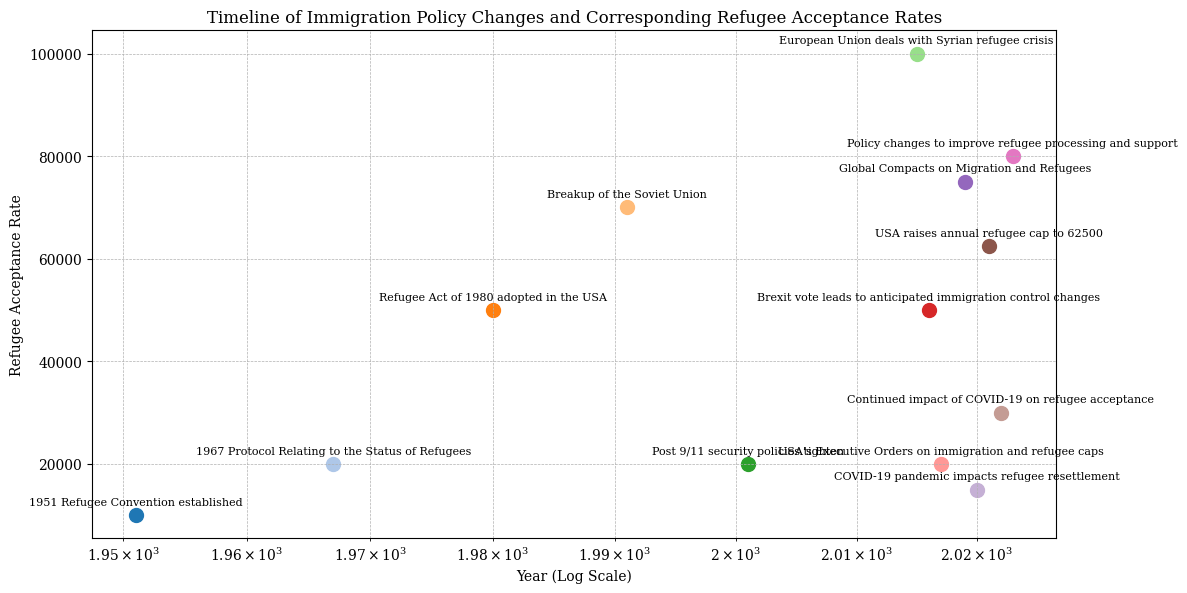What year shows the highest refugee acceptance rate, and what policy change corresponds to it? The figure shows the refugee acceptance rates along with the years they occurred and associated policy changes. The highest acceptance rate is represented by the tallest marker on the vertical axis.
Answer: 2015; European Union deals with Syrian refugee crisis Which policy change in 2023 led to an improvement in refugee acceptance rates compared to 2022, and by how much did it increase? Comparing the acceptance rates between 2022 and 2023, find their respective values: 30000 (2022) and 80000 (2023). Subtract the 2022 rate from the 2023 rate (80000 - 30000).
Answer: Policy changes to improve refugee processing and support; increased by 50,000 How did the refugee acceptance rate change post 9/11 compared to the year of the Breakup of the Soviet Union? Locate the points for the years 1991 and 2001, check the refugee acceptance rates for both: 1991 (70000), 2001 (20000). Compute the difference (70000 - 20000).
Answer: Decreased by 50,000 Between which two consecutive policy changes did the refugee acceptance rate experience the greatest absolute decrease? Examine the change in acceptance rate between consecutive years: 1951-1967, 1967-1980, 1980-1991, 1991-2001, etc. Find the pair with the largest decrease.
Answer: 1991 to 2001 Which policy change in the EU or USA had the closest refugee acceptance rate of 50,000, and in what year did it occur? Locate the years with acceptance rates close to 50,000; the policy changes for those years are linked to their countries.
Answer: 1980; Refugee Act of 1980 adopted in the USA and 2016; Brexit vote leads to anticipated immigration control changes What is the average refugee acceptance rate before and after the COVID-19 pandemic (2020), and how do they compare? Calculate the average acceptance rates before and after 2020. Before: (Sum of rates from 1951 to 2019) / Number of years before 2020. After: (Sum of rates from 2020 to 2023) / Number of years after 2020. Compare the two averages.
Answer: Before: 45000, After: 47750 Which policy change corresponds to the year the USA raised the annual refugee cap to 62500, and how does the acceptance rate compare to the year immediately before it? Identify the years and acceptance rates for 2021 and 2020: 62500 (2021), 15000 (2020). The difference (62500 - 15000).
Answer: USA raises annual refugee cap to 62500; increased by 47500 Compare the impact of the Refugee Act of 1980 and the Global Compacts on Migration and Refugees on refugee acceptance rates. Find the acceptance rates for 1980 (50000) and 2019 (75000). Determine the difference (75000 - 50000).
Answer: The Global Compacts on Migration and Refugees led to an increase by 25,000 What is the trend in refugee acceptance rates after the 1980 Refugee Act up to the post 9/11 policy change? Identify the rates and years between 1980 and 2001: 1980 (50000), 1991 (70000), 2001 (20000). Note the trend in values.
Answer: Increasing then decreasing How did the refugee acceptance rate change from 1967 to 1980, and what was the policy change related to this period? Identify rates for 1967 (20000) and 1980 (50000). Difference is (50000 - 20000). Corresponding policy change is in 1980.
Answer: Increased by 30,000; Refugee Act of 1980 adopted in the USA 